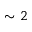Convert formula to latex. <formula><loc_0><loc_0><loc_500><loc_500>\sim 2</formula> 